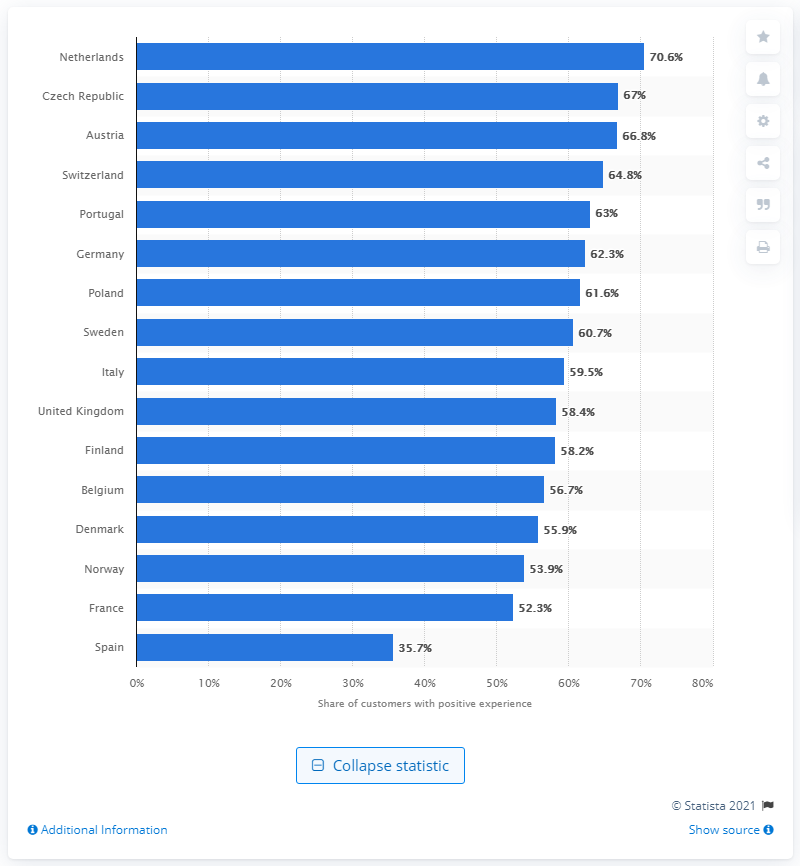Highlight a few significant elements in this photo. In 2016, 35.7% of Spanish customers reported having a positive experience. In 2016, the Czech Republic had the highest percentage of bank customers who reported having a positive experience with their bank. 